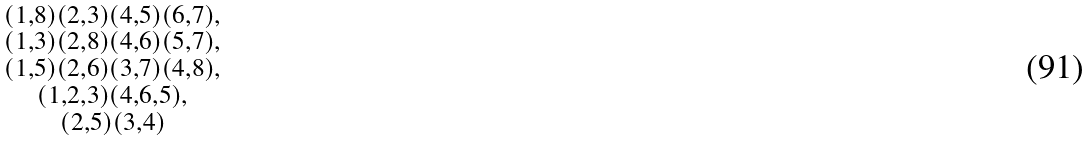Convert formula to latex. <formula><loc_0><loc_0><loc_500><loc_500>\begin{smallmatrix} ( 1 , 8 ) ( 2 , 3 ) ( 4 , 5 ) ( 6 , 7 ) , \\ ( 1 , 3 ) ( 2 , 8 ) ( 4 , 6 ) ( 5 , 7 ) , \\ ( 1 , 5 ) ( 2 , 6 ) ( 3 , 7 ) ( 4 , 8 ) , \\ ( 1 , 2 , 3 ) ( 4 , 6 , 5 ) , \\ ( 2 , 5 ) ( 3 , 4 ) \end{smallmatrix}</formula> 